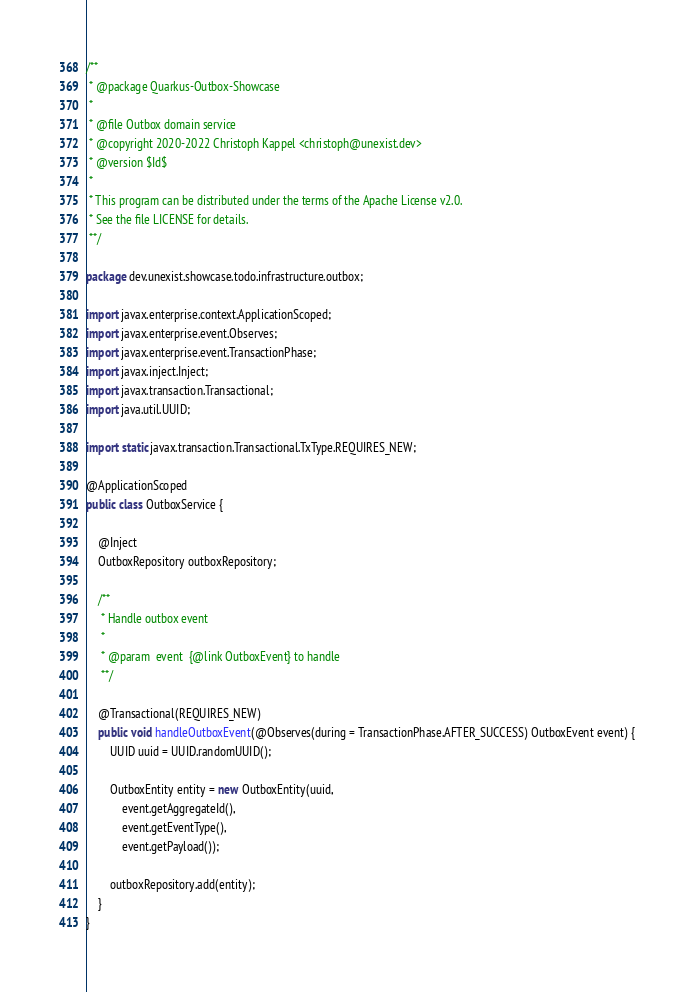Convert code to text. <code><loc_0><loc_0><loc_500><loc_500><_Java_>/**
 * @package Quarkus-Outbox-Showcase
 *
 * @file Outbox domain service
 * @copyright 2020-2022 Christoph Kappel <christoph@unexist.dev>
 * @version $Id$
 *
 * This program can be distributed under the terms of the Apache License v2.0.
 * See the file LICENSE for details.
 **/

package dev.unexist.showcase.todo.infrastructure.outbox;

import javax.enterprise.context.ApplicationScoped;
import javax.enterprise.event.Observes;
import javax.enterprise.event.TransactionPhase;
import javax.inject.Inject;
import javax.transaction.Transactional;
import java.util.UUID;

import static javax.transaction.Transactional.TxType.REQUIRES_NEW;

@ApplicationScoped
public class OutboxService {

    @Inject
    OutboxRepository outboxRepository;

    /**
     * Handle outbox event
     *
     * @param  event  {@link OutboxEvent} to handle
     **/

    @Transactional(REQUIRES_NEW)
    public void handleOutboxEvent(@Observes(during = TransactionPhase.AFTER_SUCCESS) OutboxEvent event) {
        UUID uuid = UUID.randomUUID();

        OutboxEntity entity = new OutboxEntity(uuid,
            event.getAggregateId(),
            event.getEventType(),
            event.getPayload());

        outboxRepository.add(entity);
    }
}
</code> 